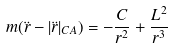Convert formula to latex. <formula><loc_0><loc_0><loc_500><loc_500>m ( \ddot { r } - | \ddot { r } | _ { C A } ) = - \frac { C } { r ^ { 2 } } + \frac { L ^ { 2 } } { r ^ { 3 } }</formula> 